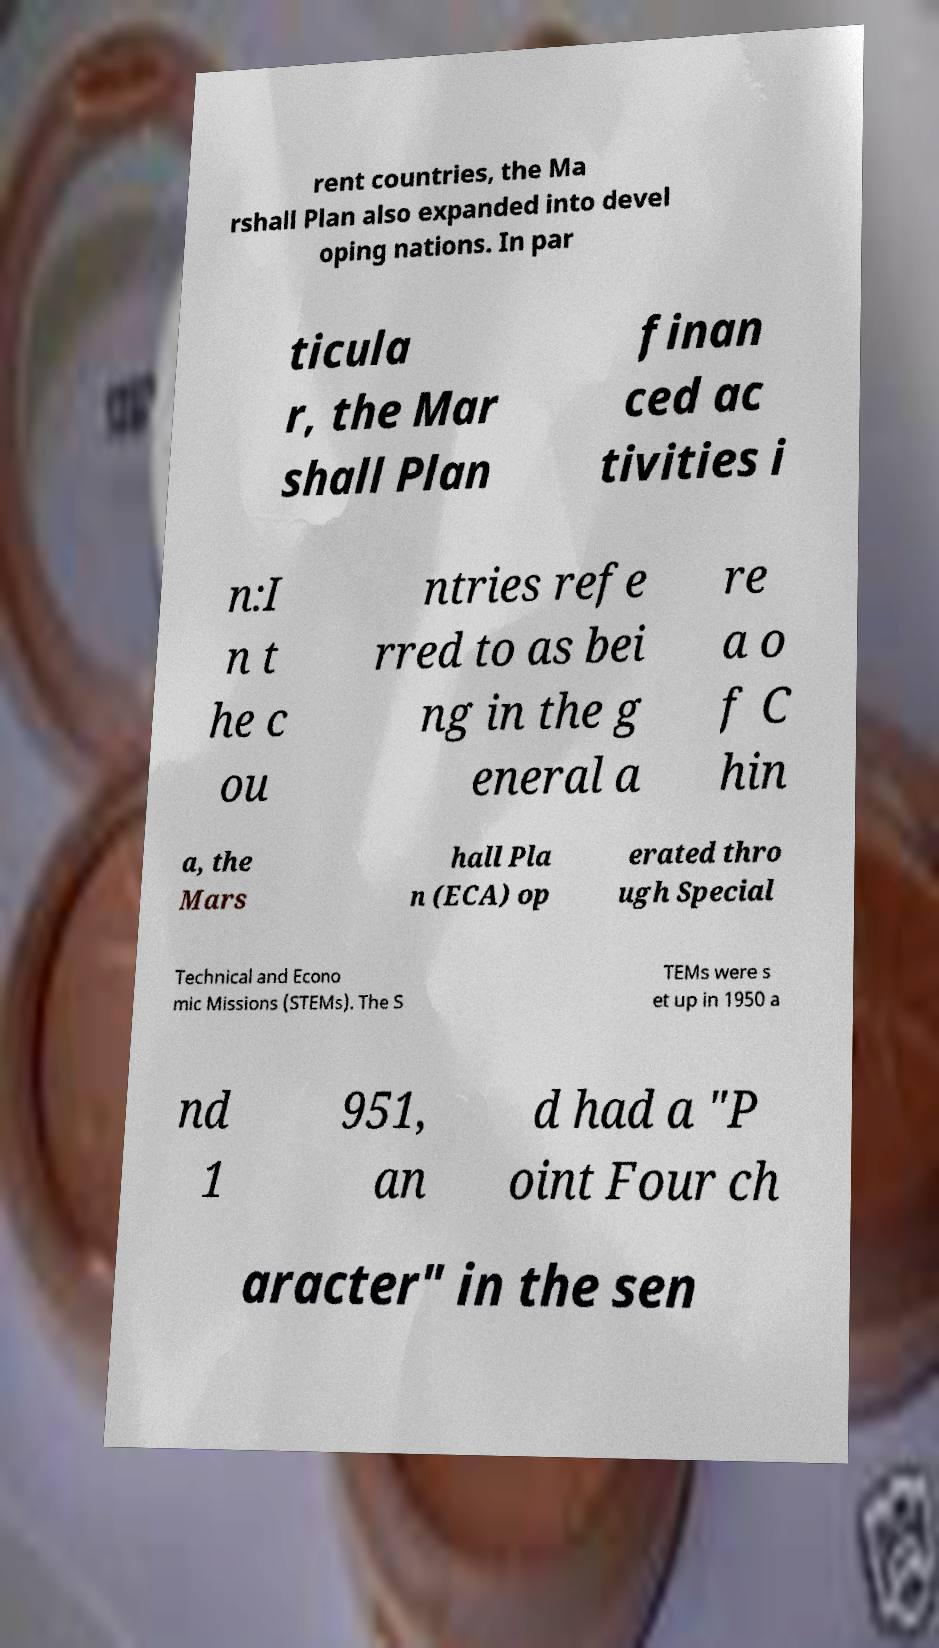Please identify and transcribe the text found in this image. rent countries, the Ma rshall Plan also expanded into devel oping nations. In par ticula r, the Mar shall Plan finan ced ac tivities i n:I n t he c ou ntries refe rred to as bei ng in the g eneral a re a o f C hin a, the Mars hall Pla n (ECA) op erated thro ugh Special Technical and Econo mic Missions (STEMs). The S TEMs were s et up in 1950 a nd 1 951, an d had a "P oint Four ch aracter" in the sen 